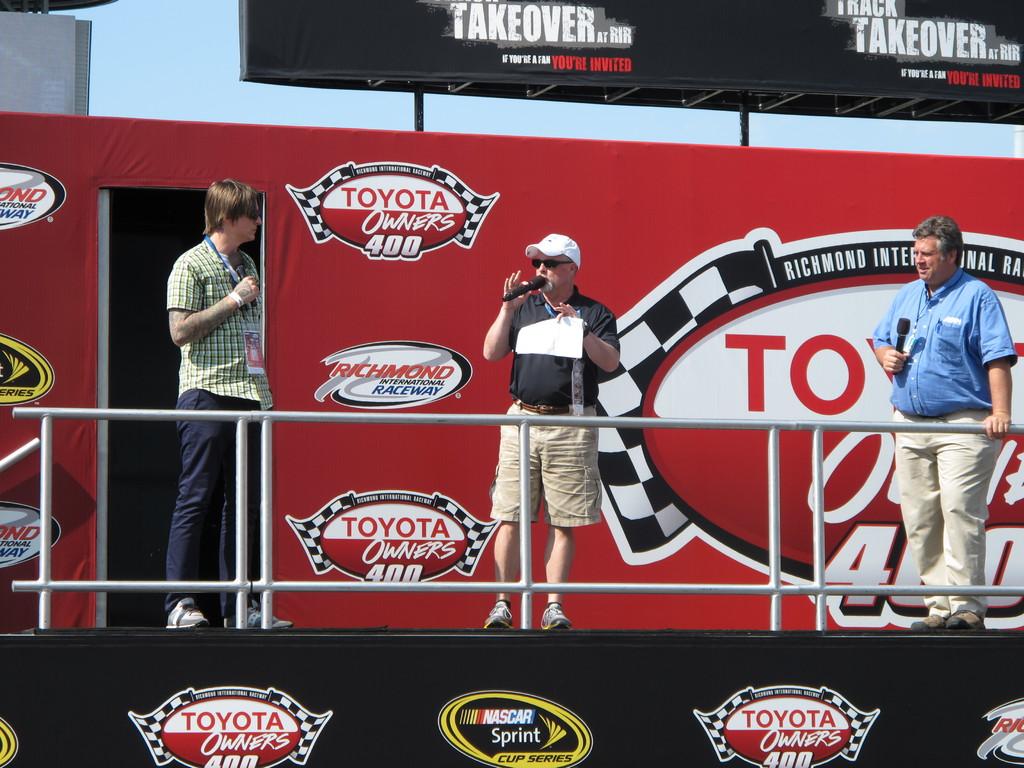Which motor company is featured?
Provide a short and direct response. Toyota. 